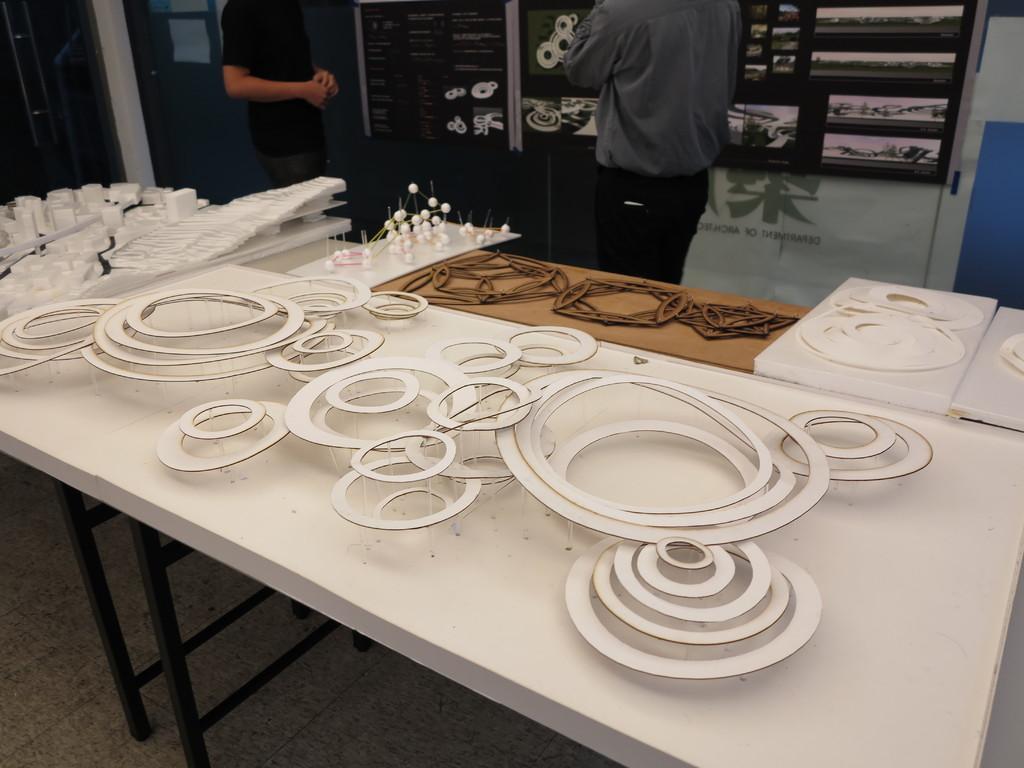In one or two sentences, can you explain what this image depicts? This image is clicked in a room. There are tables and there are two persons near the table. There are some cardboard cuttings around the table. 